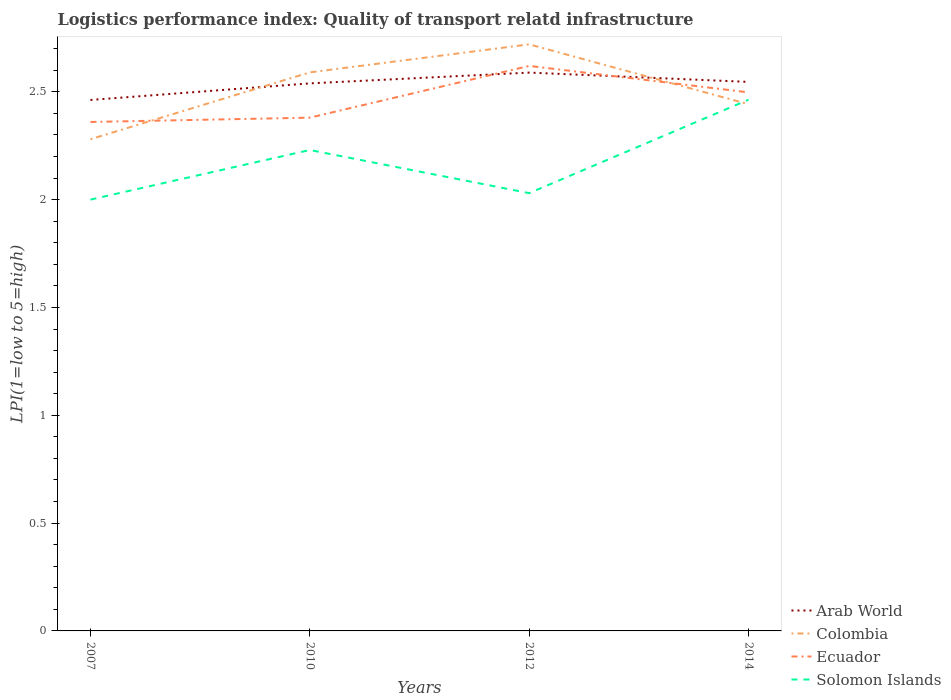Is the number of lines equal to the number of legend labels?
Your answer should be very brief. Yes. Across all years, what is the maximum logistics performance index in Solomon Islands?
Ensure brevity in your answer.  2. What is the total logistics performance index in Ecuador in the graph?
Offer a terse response. -0.24. What is the difference between the highest and the second highest logistics performance index in Colombia?
Provide a short and direct response. 0.44. Is the logistics performance index in Solomon Islands strictly greater than the logistics performance index in Arab World over the years?
Ensure brevity in your answer.  Yes. What is the difference between two consecutive major ticks on the Y-axis?
Your answer should be compact. 0.5. Are the values on the major ticks of Y-axis written in scientific E-notation?
Give a very brief answer. No. Does the graph contain any zero values?
Ensure brevity in your answer.  No. Does the graph contain grids?
Provide a succinct answer. No. How many legend labels are there?
Ensure brevity in your answer.  4. What is the title of the graph?
Provide a short and direct response. Logistics performance index: Quality of transport relatd infrastructure. Does "Jamaica" appear as one of the legend labels in the graph?
Give a very brief answer. No. What is the label or title of the X-axis?
Provide a succinct answer. Years. What is the label or title of the Y-axis?
Give a very brief answer. LPI(1=low to 5=high). What is the LPI(1=low to 5=high) of Arab World in 2007?
Your response must be concise. 2.46. What is the LPI(1=low to 5=high) of Colombia in 2007?
Your answer should be compact. 2.28. What is the LPI(1=low to 5=high) in Ecuador in 2007?
Your response must be concise. 2.36. What is the LPI(1=low to 5=high) in Arab World in 2010?
Offer a very short reply. 2.54. What is the LPI(1=low to 5=high) of Colombia in 2010?
Your answer should be very brief. 2.59. What is the LPI(1=low to 5=high) of Ecuador in 2010?
Your answer should be compact. 2.38. What is the LPI(1=low to 5=high) of Solomon Islands in 2010?
Make the answer very short. 2.23. What is the LPI(1=low to 5=high) of Arab World in 2012?
Keep it short and to the point. 2.59. What is the LPI(1=low to 5=high) of Colombia in 2012?
Give a very brief answer. 2.72. What is the LPI(1=low to 5=high) in Ecuador in 2012?
Provide a succinct answer. 2.62. What is the LPI(1=low to 5=high) in Solomon Islands in 2012?
Provide a short and direct response. 2.03. What is the LPI(1=low to 5=high) in Arab World in 2014?
Your answer should be very brief. 2.55. What is the LPI(1=low to 5=high) of Colombia in 2014?
Offer a very short reply. 2.44. What is the LPI(1=low to 5=high) of Ecuador in 2014?
Give a very brief answer. 2.5. What is the LPI(1=low to 5=high) of Solomon Islands in 2014?
Give a very brief answer. 2.46. Across all years, what is the maximum LPI(1=low to 5=high) in Arab World?
Your response must be concise. 2.59. Across all years, what is the maximum LPI(1=low to 5=high) in Colombia?
Provide a succinct answer. 2.72. Across all years, what is the maximum LPI(1=low to 5=high) of Ecuador?
Provide a succinct answer. 2.62. Across all years, what is the maximum LPI(1=low to 5=high) in Solomon Islands?
Ensure brevity in your answer.  2.46. Across all years, what is the minimum LPI(1=low to 5=high) of Arab World?
Provide a succinct answer. 2.46. Across all years, what is the minimum LPI(1=low to 5=high) of Colombia?
Keep it short and to the point. 2.28. Across all years, what is the minimum LPI(1=low to 5=high) of Ecuador?
Make the answer very short. 2.36. Across all years, what is the minimum LPI(1=low to 5=high) of Solomon Islands?
Your response must be concise. 2. What is the total LPI(1=low to 5=high) of Arab World in the graph?
Your response must be concise. 10.14. What is the total LPI(1=low to 5=high) of Colombia in the graph?
Offer a very short reply. 10.03. What is the total LPI(1=low to 5=high) in Ecuador in the graph?
Keep it short and to the point. 9.86. What is the total LPI(1=low to 5=high) of Solomon Islands in the graph?
Ensure brevity in your answer.  8.72. What is the difference between the LPI(1=low to 5=high) in Arab World in 2007 and that in 2010?
Your answer should be very brief. -0.08. What is the difference between the LPI(1=low to 5=high) in Colombia in 2007 and that in 2010?
Provide a succinct answer. -0.31. What is the difference between the LPI(1=low to 5=high) of Ecuador in 2007 and that in 2010?
Give a very brief answer. -0.02. What is the difference between the LPI(1=low to 5=high) in Solomon Islands in 2007 and that in 2010?
Your response must be concise. -0.23. What is the difference between the LPI(1=low to 5=high) of Arab World in 2007 and that in 2012?
Make the answer very short. -0.13. What is the difference between the LPI(1=low to 5=high) in Colombia in 2007 and that in 2012?
Your answer should be compact. -0.44. What is the difference between the LPI(1=low to 5=high) in Ecuador in 2007 and that in 2012?
Your answer should be very brief. -0.26. What is the difference between the LPI(1=low to 5=high) in Solomon Islands in 2007 and that in 2012?
Your response must be concise. -0.03. What is the difference between the LPI(1=low to 5=high) in Arab World in 2007 and that in 2014?
Your answer should be compact. -0.08. What is the difference between the LPI(1=low to 5=high) of Colombia in 2007 and that in 2014?
Provide a short and direct response. -0.16. What is the difference between the LPI(1=low to 5=high) in Ecuador in 2007 and that in 2014?
Give a very brief answer. -0.14. What is the difference between the LPI(1=low to 5=high) in Solomon Islands in 2007 and that in 2014?
Offer a very short reply. -0.46. What is the difference between the LPI(1=low to 5=high) in Arab World in 2010 and that in 2012?
Keep it short and to the point. -0.05. What is the difference between the LPI(1=low to 5=high) in Colombia in 2010 and that in 2012?
Offer a very short reply. -0.13. What is the difference between the LPI(1=low to 5=high) in Ecuador in 2010 and that in 2012?
Offer a terse response. -0.24. What is the difference between the LPI(1=low to 5=high) of Solomon Islands in 2010 and that in 2012?
Give a very brief answer. 0.2. What is the difference between the LPI(1=low to 5=high) of Arab World in 2010 and that in 2014?
Offer a terse response. -0.01. What is the difference between the LPI(1=low to 5=high) in Colombia in 2010 and that in 2014?
Provide a succinct answer. 0.15. What is the difference between the LPI(1=low to 5=high) in Ecuador in 2010 and that in 2014?
Your answer should be very brief. -0.12. What is the difference between the LPI(1=low to 5=high) of Solomon Islands in 2010 and that in 2014?
Offer a very short reply. -0.23. What is the difference between the LPI(1=low to 5=high) of Arab World in 2012 and that in 2014?
Offer a very short reply. 0.04. What is the difference between the LPI(1=low to 5=high) in Colombia in 2012 and that in 2014?
Provide a short and direct response. 0.28. What is the difference between the LPI(1=low to 5=high) of Ecuador in 2012 and that in 2014?
Offer a terse response. 0.12. What is the difference between the LPI(1=low to 5=high) of Solomon Islands in 2012 and that in 2014?
Make the answer very short. -0.43. What is the difference between the LPI(1=low to 5=high) in Arab World in 2007 and the LPI(1=low to 5=high) in Colombia in 2010?
Keep it short and to the point. -0.13. What is the difference between the LPI(1=low to 5=high) of Arab World in 2007 and the LPI(1=low to 5=high) of Ecuador in 2010?
Provide a short and direct response. 0.08. What is the difference between the LPI(1=low to 5=high) of Arab World in 2007 and the LPI(1=low to 5=high) of Solomon Islands in 2010?
Make the answer very short. 0.23. What is the difference between the LPI(1=low to 5=high) in Colombia in 2007 and the LPI(1=low to 5=high) in Ecuador in 2010?
Provide a short and direct response. -0.1. What is the difference between the LPI(1=low to 5=high) of Colombia in 2007 and the LPI(1=low to 5=high) of Solomon Islands in 2010?
Offer a terse response. 0.05. What is the difference between the LPI(1=low to 5=high) of Ecuador in 2007 and the LPI(1=low to 5=high) of Solomon Islands in 2010?
Your response must be concise. 0.13. What is the difference between the LPI(1=low to 5=high) in Arab World in 2007 and the LPI(1=low to 5=high) in Colombia in 2012?
Your answer should be very brief. -0.26. What is the difference between the LPI(1=low to 5=high) in Arab World in 2007 and the LPI(1=low to 5=high) in Ecuador in 2012?
Give a very brief answer. -0.16. What is the difference between the LPI(1=low to 5=high) in Arab World in 2007 and the LPI(1=low to 5=high) in Solomon Islands in 2012?
Your answer should be compact. 0.43. What is the difference between the LPI(1=low to 5=high) in Colombia in 2007 and the LPI(1=low to 5=high) in Ecuador in 2012?
Provide a short and direct response. -0.34. What is the difference between the LPI(1=low to 5=high) in Ecuador in 2007 and the LPI(1=low to 5=high) in Solomon Islands in 2012?
Offer a terse response. 0.33. What is the difference between the LPI(1=low to 5=high) in Arab World in 2007 and the LPI(1=low to 5=high) in Colombia in 2014?
Offer a terse response. 0.02. What is the difference between the LPI(1=low to 5=high) of Arab World in 2007 and the LPI(1=low to 5=high) of Ecuador in 2014?
Keep it short and to the point. -0.04. What is the difference between the LPI(1=low to 5=high) in Arab World in 2007 and the LPI(1=low to 5=high) in Solomon Islands in 2014?
Provide a short and direct response. -0. What is the difference between the LPI(1=low to 5=high) in Colombia in 2007 and the LPI(1=low to 5=high) in Ecuador in 2014?
Keep it short and to the point. -0.22. What is the difference between the LPI(1=low to 5=high) in Colombia in 2007 and the LPI(1=low to 5=high) in Solomon Islands in 2014?
Give a very brief answer. -0.18. What is the difference between the LPI(1=low to 5=high) of Ecuador in 2007 and the LPI(1=low to 5=high) of Solomon Islands in 2014?
Your response must be concise. -0.1. What is the difference between the LPI(1=low to 5=high) in Arab World in 2010 and the LPI(1=low to 5=high) in Colombia in 2012?
Provide a short and direct response. -0.18. What is the difference between the LPI(1=low to 5=high) of Arab World in 2010 and the LPI(1=low to 5=high) of Ecuador in 2012?
Your answer should be compact. -0.08. What is the difference between the LPI(1=low to 5=high) in Arab World in 2010 and the LPI(1=low to 5=high) in Solomon Islands in 2012?
Offer a very short reply. 0.51. What is the difference between the LPI(1=low to 5=high) in Colombia in 2010 and the LPI(1=low to 5=high) in Ecuador in 2012?
Give a very brief answer. -0.03. What is the difference between the LPI(1=low to 5=high) in Colombia in 2010 and the LPI(1=low to 5=high) in Solomon Islands in 2012?
Make the answer very short. 0.56. What is the difference between the LPI(1=low to 5=high) in Arab World in 2010 and the LPI(1=low to 5=high) in Colombia in 2014?
Your response must be concise. 0.1. What is the difference between the LPI(1=low to 5=high) of Arab World in 2010 and the LPI(1=low to 5=high) of Ecuador in 2014?
Your answer should be very brief. 0.04. What is the difference between the LPI(1=low to 5=high) of Arab World in 2010 and the LPI(1=low to 5=high) of Solomon Islands in 2014?
Make the answer very short. 0.08. What is the difference between the LPI(1=low to 5=high) in Colombia in 2010 and the LPI(1=low to 5=high) in Ecuador in 2014?
Your answer should be compact. 0.09. What is the difference between the LPI(1=low to 5=high) in Colombia in 2010 and the LPI(1=low to 5=high) in Solomon Islands in 2014?
Give a very brief answer. 0.13. What is the difference between the LPI(1=low to 5=high) in Ecuador in 2010 and the LPI(1=low to 5=high) in Solomon Islands in 2014?
Give a very brief answer. -0.08. What is the difference between the LPI(1=low to 5=high) in Arab World in 2012 and the LPI(1=low to 5=high) in Colombia in 2014?
Offer a terse response. 0.15. What is the difference between the LPI(1=low to 5=high) of Arab World in 2012 and the LPI(1=low to 5=high) of Ecuador in 2014?
Ensure brevity in your answer.  0.09. What is the difference between the LPI(1=low to 5=high) of Arab World in 2012 and the LPI(1=low to 5=high) of Solomon Islands in 2014?
Ensure brevity in your answer.  0.13. What is the difference between the LPI(1=low to 5=high) of Colombia in 2012 and the LPI(1=low to 5=high) of Ecuador in 2014?
Your response must be concise. 0.22. What is the difference between the LPI(1=low to 5=high) in Colombia in 2012 and the LPI(1=low to 5=high) in Solomon Islands in 2014?
Make the answer very short. 0.26. What is the difference between the LPI(1=low to 5=high) in Ecuador in 2012 and the LPI(1=low to 5=high) in Solomon Islands in 2014?
Give a very brief answer. 0.16. What is the average LPI(1=low to 5=high) in Arab World per year?
Keep it short and to the point. 2.53. What is the average LPI(1=low to 5=high) in Colombia per year?
Make the answer very short. 2.51. What is the average LPI(1=low to 5=high) of Ecuador per year?
Your answer should be very brief. 2.46. What is the average LPI(1=low to 5=high) in Solomon Islands per year?
Offer a terse response. 2.18. In the year 2007, what is the difference between the LPI(1=low to 5=high) of Arab World and LPI(1=low to 5=high) of Colombia?
Offer a very short reply. 0.18. In the year 2007, what is the difference between the LPI(1=low to 5=high) of Arab World and LPI(1=low to 5=high) of Ecuador?
Keep it short and to the point. 0.1. In the year 2007, what is the difference between the LPI(1=low to 5=high) in Arab World and LPI(1=low to 5=high) in Solomon Islands?
Your answer should be compact. 0.46. In the year 2007, what is the difference between the LPI(1=low to 5=high) of Colombia and LPI(1=low to 5=high) of Ecuador?
Offer a very short reply. -0.08. In the year 2007, what is the difference between the LPI(1=low to 5=high) of Colombia and LPI(1=low to 5=high) of Solomon Islands?
Provide a short and direct response. 0.28. In the year 2007, what is the difference between the LPI(1=low to 5=high) of Ecuador and LPI(1=low to 5=high) of Solomon Islands?
Keep it short and to the point. 0.36. In the year 2010, what is the difference between the LPI(1=low to 5=high) of Arab World and LPI(1=low to 5=high) of Colombia?
Make the answer very short. -0.05. In the year 2010, what is the difference between the LPI(1=low to 5=high) in Arab World and LPI(1=low to 5=high) in Ecuador?
Offer a terse response. 0.16. In the year 2010, what is the difference between the LPI(1=low to 5=high) of Arab World and LPI(1=low to 5=high) of Solomon Islands?
Offer a very short reply. 0.31. In the year 2010, what is the difference between the LPI(1=low to 5=high) in Colombia and LPI(1=low to 5=high) in Ecuador?
Provide a succinct answer. 0.21. In the year 2010, what is the difference between the LPI(1=low to 5=high) of Colombia and LPI(1=low to 5=high) of Solomon Islands?
Ensure brevity in your answer.  0.36. In the year 2012, what is the difference between the LPI(1=low to 5=high) of Arab World and LPI(1=low to 5=high) of Colombia?
Ensure brevity in your answer.  -0.13. In the year 2012, what is the difference between the LPI(1=low to 5=high) of Arab World and LPI(1=low to 5=high) of Ecuador?
Your response must be concise. -0.03. In the year 2012, what is the difference between the LPI(1=low to 5=high) of Arab World and LPI(1=low to 5=high) of Solomon Islands?
Provide a succinct answer. 0.56. In the year 2012, what is the difference between the LPI(1=low to 5=high) in Colombia and LPI(1=low to 5=high) in Solomon Islands?
Provide a succinct answer. 0.69. In the year 2012, what is the difference between the LPI(1=low to 5=high) in Ecuador and LPI(1=low to 5=high) in Solomon Islands?
Make the answer very short. 0.59. In the year 2014, what is the difference between the LPI(1=low to 5=high) in Arab World and LPI(1=low to 5=high) in Colombia?
Offer a very short reply. 0.1. In the year 2014, what is the difference between the LPI(1=low to 5=high) of Arab World and LPI(1=low to 5=high) of Ecuador?
Give a very brief answer. 0.05. In the year 2014, what is the difference between the LPI(1=low to 5=high) in Arab World and LPI(1=low to 5=high) in Solomon Islands?
Make the answer very short. 0.08. In the year 2014, what is the difference between the LPI(1=low to 5=high) in Colombia and LPI(1=low to 5=high) in Ecuador?
Give a very brief answer. -0.06. In the year 2014, what is the difference between the LPI(1=low to 5=high) in Colombia and LPI(1=low to 5=high) in Solomon Islands?
Offer a very short reply. -0.02. In the year 2014, what is the difference between the LPI(1=low to 5=high) of Ecuador and LPI(1=low to 5=high) of Solomon Islands?
Your response must be concise. 0.03. What is the ratio of the LPI(1=low to 5=high) in Arab World in 2007 to that in 2010?
Your answer should be compact. 0.97. What is the ratio of the LPI(1=low to 5=high) of Colombia in 2007 to that in 2010?
Provide a short and direct response. 0.88. What is the ratio of the LPI(1=low to 5=high) of Ecuador in 2007 to that in 2010?
Your response must be concise. 0.99. What is the ratio of the LPI(1=low to 5=high) in Solomon Islands in 2007 to that in 2010?
Your answer should be very brief. 0.9. What is the ratio of the LPI(1=low to 5=high) of Arab World in 2007 to that in 2012?
Keep it short and to the point. 0.95. What is the ratio of the LPI(1=low to 5=high) of Colombia in 2007 to that in 2012?
Provide a short and direct response. 0.84. What is the ratio of the LPI(1=low to 5=high) in Ecuador in 2007 to that in 2012?
Your answer should be very brief. 0.9. What is the ratio of the LPI(1=low to 5=high) in Solomon Islands in 2007 to that in 2012?
Ensure brevity in your answer.  0.99. What is the ratio of the LPI(1=low to 5=high) of Arab World in 2007 to that in 2014?
Keep it short and to the point. 0.97. What is the ratio of the LPI(1=low to 5=high) in Colombia in 2007 to that in 2014?
Keep it short and to the point. 0.93. What is the ratio of the LPI(1=low to 5=high) in Ecuador in 2007 to that in 2014?
Give a very brief answer. 0.94. What is the ratio of the LPI(1=low to 5=high) of Solomon Islands in 2007 to that in 2014?
Keep it short and to the point. 0.81. What is the ratio of the LPI(1=low to 5=high) of Arab World in 2010 to that in 2012?
Make the answer very short. 0.98. What is the ratio of the LPI(1=low to 5=high) of Colombia in 2010 to that in 2012?
Provide a succinct answer. 0.95. What is the ratio of the LPI(1=low to 5=high) of Ecuador in 2010 to that in 2012?
Provide a succinct answer. 0.91. What is the ratio of the LPI(1=low to 5=high) in Solomon Islands in 2010 to that in 2012?
Provide a succinct answer. 1.1. What is the ratio of the LPI(1=low to 5=high) of Arab World in 2010 to that in 2014?
Offer a very short reply. 1. What is the ratio of the LPI(1=low to 5=high) of Colombia in 2010 to that in 2014?
Offer a very short reply. 1.06. What is the ratio of the LPI(1=low to 5=high) of Ecuador in 2010 to that in 2014?
Provide a succinct answer. 0.95. What is the ratio of the LPI(1=low to 5=high) of Solomon Islands in 2010 to that in 2014?
Ensure brevity in your answer.  0.91. What is the ratio of the LPI(1=low to 5=high) in Arab World in 2012 to that in 2014?
Your response must be concise. 1.02. What is the ratio of the LPI(1=low to 5=high) in Colombia in 2012 to that in 2014?
Your answer should be compact. 1.11. What is the ratio of the LPI(1=low to 5=high) of Ecuador in 2012 to that in 2014?
Your response must be concise. 1.05. What is the ratio of the LPI(1=low to 5=high) of Solomon Islands in 2012 to that in 2014?
Provide a succinct answer. 0.82. What is the difference between the highest and the second highest LPI(1=low to 5=high) in Arab World?
Your answer should be compact. 0.04. What is the difference between the highest and the second highest LPI(1=low to 5=high) of Colombia?
Your answer should be very brief. 0.13. What is the difference between the highest and the second highest LPI(1=low to 5=high) in Ecuador?
Ensure brevity in your answer.  0.12. What is the difference between the highest and the second highest LPI(1=low to 5=high) in Solomon Islands?
Provide a short and direct response. 0.23. What is the difference between the highest and the lowest LPI(1=low to 5=high) in Arab World?
Your answer should be compact. 0.13. What is the difference between the highest and the lowest LPI(1=low to 5=high) in Colombia?
Offer a very short reply. 0.44. What is the difference between the highest and the lowest LPI(1=low to 5=high) of Ecuador?
Your response must be concise. 0.26. What is the difference between the highest and the lowest LPI(1=low to 5=high) in Solomon Islands?
Make the answer very short. 0.46. 